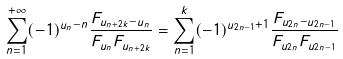<formula> <loc_0><loc_0><loc_500><loc_500>\sum _ { n = 1 } ^ { + \infty } ( - 1 ) ^ { u _ { n } - n } \frac { F _ { u _ { n + 2 k } - u _ { n } } } { F _ { u _ { n } } F _ { u _ { n + 2 k } } } = \sum _ { n = 1 } ^ { k } ( - 1 ) ^ { u _ { 2 n - 1 } + 1 } \frac { F _ { u _ { 2 n } - u _ { 2 n - 1 } } } { F _ { u _ { 2 n } } F _ { u _ { 2 n - 1 } } }</formula> 